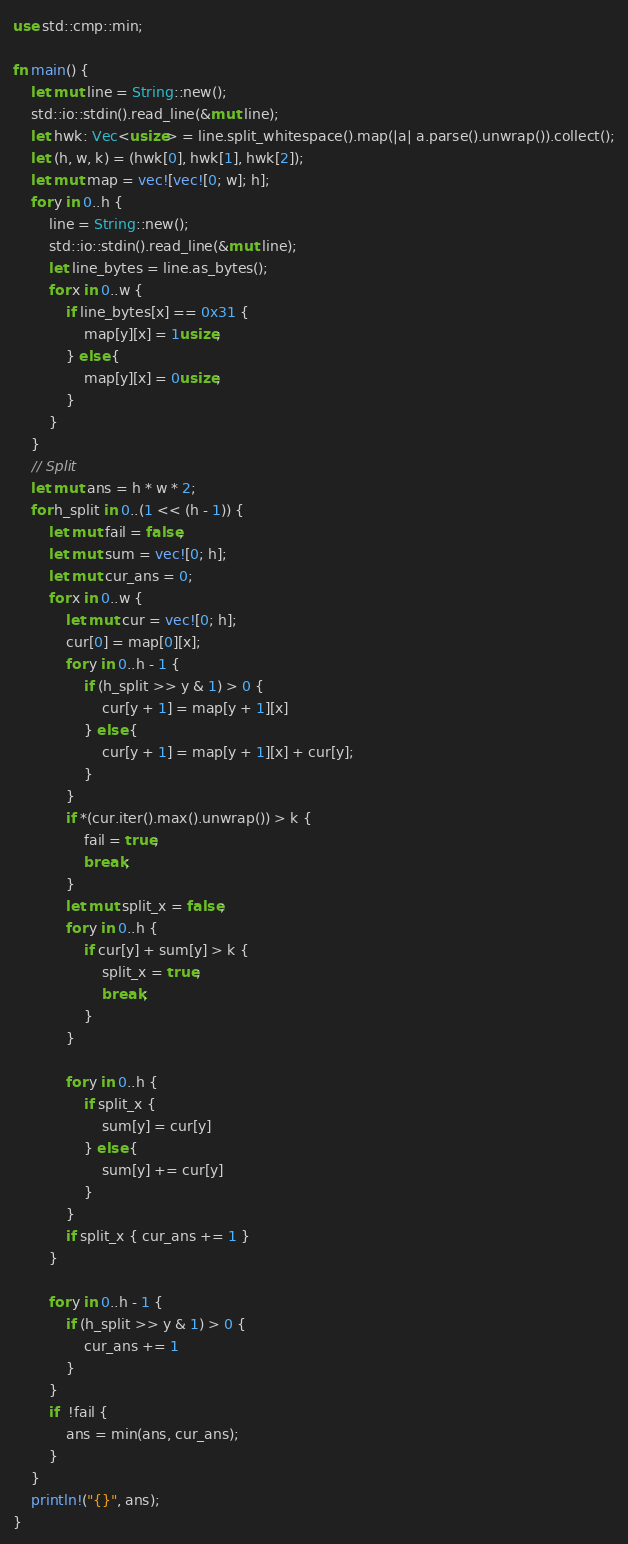Convert code to text. <code><loc_0><loc_0><loc_500><loc_500><_Rust_>use std::cmp::min;

fn main() {
    let mut line = String::new();
    std::io::stdin().read_line(&mut line);
    let hwk: Vec<usize> = line.split_whitespace().map(|a| a.parse().unwrap()).collect();
    let (h, w, k) = (hwk[0], hwk[1], hwk[2]);
    let mut map = vec![vec![0; w]; h];
    for y in 0..h {
        line = String::new();
        std::io::stdin().read_line(&mut line);
        let line_bytes = line.as_bytes();
        for x in 0..w {
            if line_bytes[x] == 0x31 {
                map[y][x] = 1usize;
            } else {
                map[y][x] = 0usize;
            }
        }
    }
    // Split
    let mut ans = h * w * 2;
    for h_split in 0..(1 << (h - 1)) {
        let mut fail = false;
        let mut sum = vec![0; h];
        let mut cur_ans = 0;
        for x in 0..w {
            let mut cur = vec![0; h];
            cur[0] = map[0][x];
            for y in 0..h - 1 {
                if (h_split >> y & 1) > 0 {
                    cur[y + 1] = map[y + 1][x]
                } else {
                    cur[y + 1] = map[y + 1][x] + cur[y];
                }
            }
            if *(cur.iter().max().unwrap()) > k {
                fail = true;
                break;
            }
            let mut split_x = false;
            for y in 0..h {
                if cur[y] + sum[y] > k {
                    split_x = true;
                    break;
                }
            }

            for y in 0..h {
                if split_x {
                    sum[y] = cur[y]
                } else {
                    sum[y] += cur[y]
                }
            }
            if split_x { cur_ans += 1 }
        }

        for y in 0..h - 1 {
            if (h_split >> y & 1) > 0 {
                cur_ans += 1
            }
        }
        if  !fail {
            ans = min(ans, cur_ans);
        }
    }
    println!("{}", ans);
}
</code> 